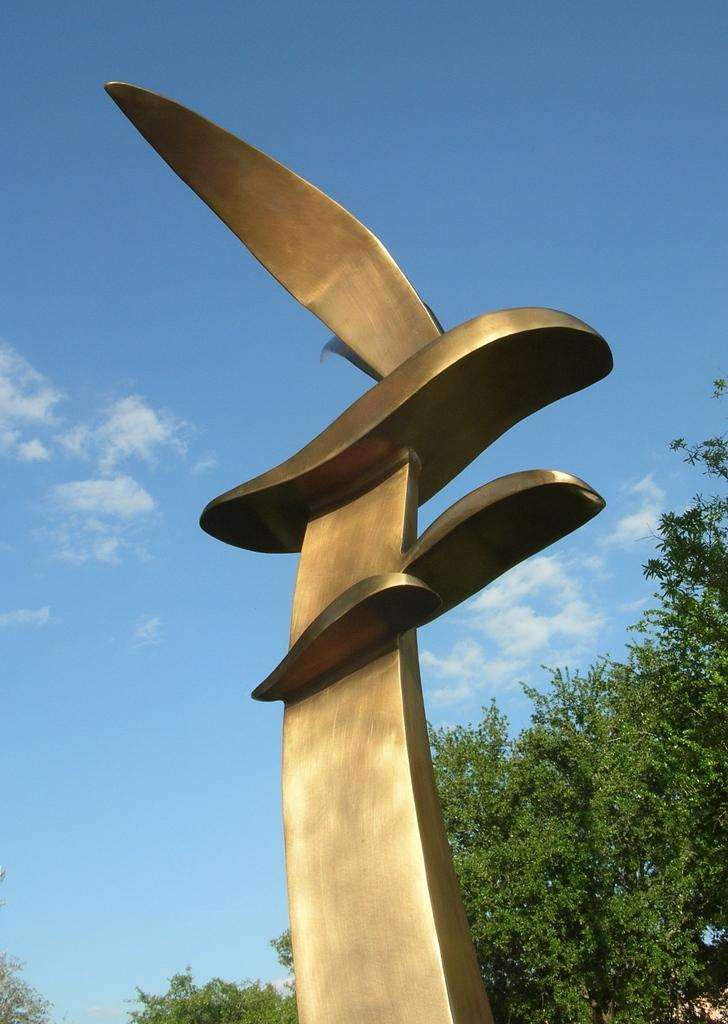What is the main subject in the middle of the image? There is a statue in the middle of the image. What can be seen in the background of the image? There are trees in the background of the image. What is visible in the sky in the image? There are clouds in the sky, and the sky is blue. What type of bread can be seen in the statue's hand in the image? There is no bread or loaf present in the image, and the statue does not have a hand. 